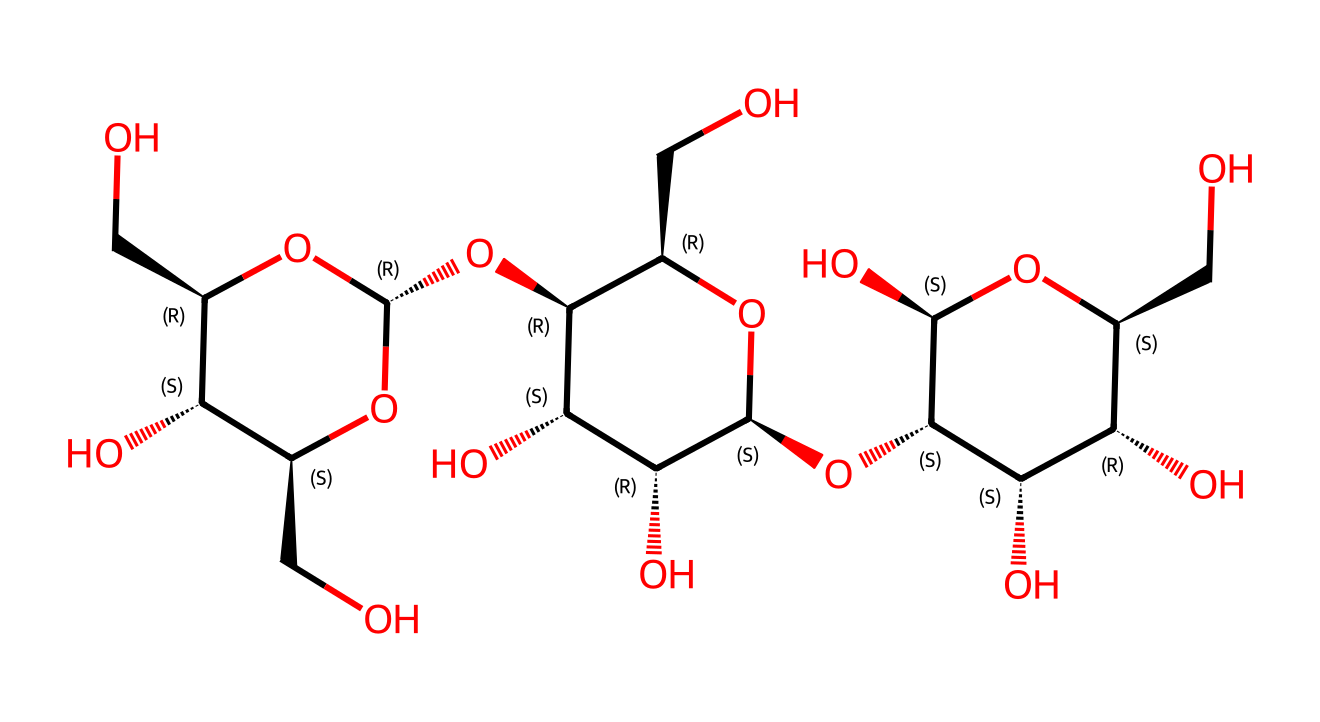What is the element that primarily constitutes bamboo fibers? The chemical structure showcases multiple carbon and oxygen atoms, indicating that bamboo fibers are primarily composed of cellulose, which contains a significant amount of carbon.
Answer: cellulose How many hydroxyl groups are present in the structure? By examining the chemical structure, we can count the hydroxyl groups (-OH), which are highlighted as part of the multiple functional groups connected to the carbon atoms. In this case, there are six hydroxyl groups present.
Answer: six Does this chemical structure indicate any branches, and if so, how many? Branching can be identified by looking for the points where the main chain of carbon atoms diverges or connects to other groups. In this structure, there are two notable branches connected at specific points, indicating branching in the molecule.
Answer: two What type of bonds are primarily present in bamboo fibers as indicated by this structure? The structure features multiple single bonds between carbon and oxygen atoms, and it also indicates the presence of ether and alcohol linkages, typical for polysaccharide structures. This suggests that the primary bond types are covalent bonds.
Answer: covalent bonds What functional groups are evident in the chemical structure of bamboo fibers? Observing the structure, we can identify hydroxyl (-OH) groups and ether linkages, which are typical functional groups of polysaccharides like cellulose. These groups are crucial for the material's solubility and biodegradability.
Answer: hydroxyl and ether groups 